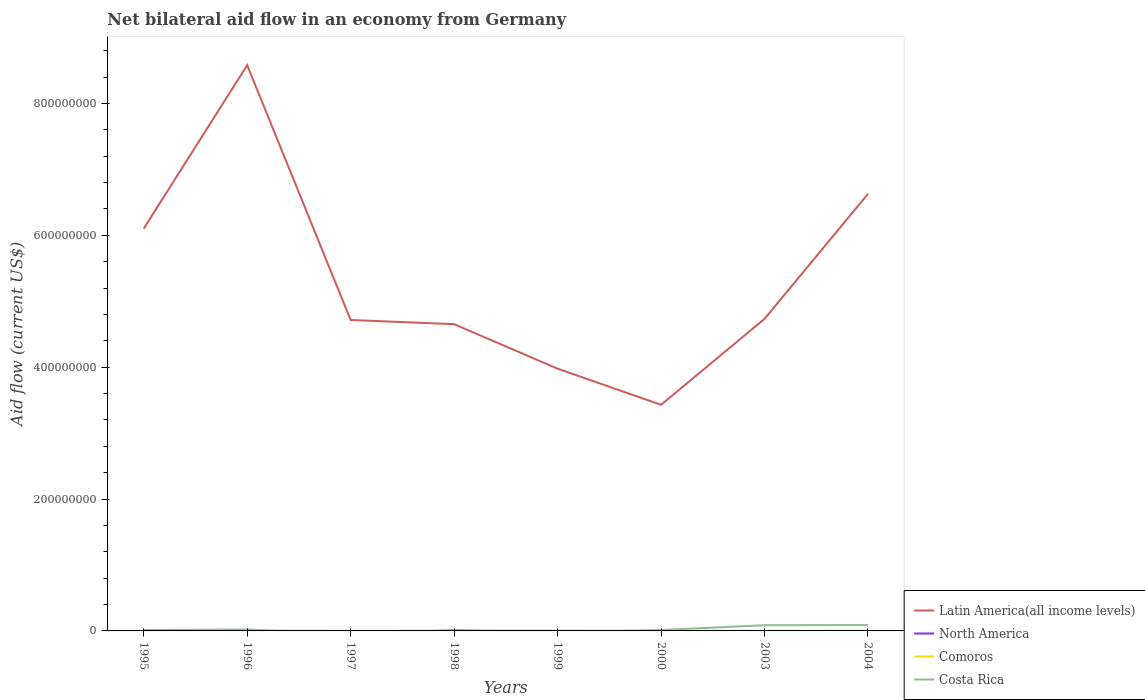Across all years, what is the maximum net bilateral aid flow in Comoros?
Your answer should be very brief. 2.00e+04. What is the total net bilateral aid flow in Latin America(all income levels) in the graph?
Provide a succinct answer. 5.15e+08. What is the difference between the highest and the second highest net bilateral aid flow in Comoros?
Keep it short and to the point. 9.30e+05. How many lines are there?
Offer a terse response. 4. How are the legend labels stacked?
Give a very brief answer. Vertical. What is the title of the graph?
Your answer should be very brief. Net bilateral aid flow in an economy from Germany. What is the Aid flow (current US$) in Latin America(all income levels) in 1995?
Your answer should be compact. 6.10e+08. What is the Aid flow (current US$) in Costa Rica in 1995?
Offer a terse response. 1.34e+06. What is the Aid flow (current US$) of Latin America(all income levels) in 1996?
Your response must be concise. 8.58e+08. What is the Aid flow (current US$) in North America in 1996?
Offer a very short reply. 0. What is the Aid flow (current US$) of Comoros in 1996?
Offer a very short reply. 9.50e+05. What is the Aid flow (current US$) of Costa Rica in 1996?
Offer a very short reply. 2.22e+06. What is the Aid flow (current US$) of Latin America(all income levels) in 1997?
Your answer should be compact. 4.72e+08. What is the Aid flow (current US$) in North America in 1997?
Provide a short and direct response. 0. What is the Aid flow (current US$) of Comoros in 1997?
Give a very brief answer. 2.60e+05. What is the Aid flow (current US$) of Latin America(all income levels) in 1998?
Keep it short and to the point. 4.65e+08. What is the Aid flow (current US$) in Comoros in 1998?
Your answer should be very brief. 6.00e+05. What is the Aid flow (current US$) in Costa Rica in 1998?
Your answer should be very brief. 1.49e+06. What is the Aid flow (current US$) of Latin America(all income levels) in 1999?
Give a very brief answer. 3.98e+08. What is the Aid flow (current US$) of North America in 1999?
Ensure brevity in your answer.  2.00e+04. What is the Aid flow (current US$) in Comoros in 1999?
Give a very brief answer. 4.20e+05. What is the Aid flow (current US$) in Latin America(all income levels) in 2000?
Your answer should be compact. 3.43e+08. What is the Aid flow (current US$) of North America in 2000?
Ensure brevity in your answer.  10000. What is the Aid flow (current US$) in Costa Rica in 2000?
Make the answer very short. 1.39e+06. What is the Aid flow (current US$) of Latin America(all income levels) in 2003?
Your answer should be compact. 4.73e+08. What is the Aid flow (current US$) of North America in 2003?
Keep it short and to the point. 10000. What is the Aid flow (current US$) of Costa Rica in 2003?
Provide a short and direct response. 8.62e+06. What is the Aid flow (current US$) in Latin America(all income levels) in 2004?
Ensure brevity in your answer.  6.63e+08. What is the Aid flow (current US$) of North America in 2004?
Your answer should be very brief. 3.00e+04. What is the Aid flow (current US$) in Costa Rica in 2004?
Ensure brevity in your answer.  8.91e+06. Across all years, what is the maximum Aid flow (current US$) of Latin America(all income levels)?
Provide a succinct answer. 8.58e+08. Across all years, what is the maximum Aid flow (current US$) of North America?
Your response must be concise. 3.00e+04. Across all years, what is the maximum Aid flow (current US$) of Comoros?
Keep it short and to the point. 9.50e+05. Across all years, what is the maximum Aid flow (current US$) of Costa Rica?
Provide a short and direct response. 8.91e+06. Across all years, what is the minimum Aid flow (current US$) in Latin America(all income levels)?
Provide a short and direct response. 3.43e+08. Across all years, what is the minimum Aid flow (current US$) in Comoros?
Your answer should be very brief. 2.00e+04. What is the total Aid flow (current US$) in Latin America(all income levels) in the graph?
Your answer should be compact. 4.28e+09. What is the total Aid flow (current US$) in Comoros in the graph?
Provide a succinct answer. 2.53e+06. What is the total Aid flow (current US$) of Costa Rica in the graph?
Make the answer very short. 2.40e+07. What is the difference between the Aid flow (current US$) in Latin America(all income levels) in 1995 and that in 1996?
Provide a succinct answer. -2.48e+08. What is the difference between the Aid flow (current US$) of Comoros in 1995 and that in 1996?
Your response must be concise. -7.40e+05. What is the difference between the Aid flow (current US$) in Costa Rica in 1995 and that in 1996?
Make the answer very short. -8.80e+05. What is the difference between the Aid flow (current US$) of Latin America(all income levels) in 1995 and that in 1997?
Provide a succinct answer. 1.39e+08. What is the difference between the Aid flow (current US$) in Latin America(all income levels) in 1995 and that in 1998?
Keep it short and to the point. 1.45e+08. What is the difference between the Aid flow (current US$) of Comoros in 1995 and that in 1998?
Ensure brevity in your answer.  -3.90e+05. What is the difference between the Aid flow (current US$) in Costa Rica in 1995 and that in 1998?
Provide a short and direct response. -1.50e+05. What is the difference between the Aid flow (current US$) in Latin America(all income levels) in 1995 and that in 1999?
Provide a succinct answer. 2.12e+08. What is the difference between the Aid flow (current US$) in Comoros in 1995 and that in 1999?
Offer a terse response. -2.10e+05. What is the difference between the Aid flow (current US$) of Latin America(all income levels) in 1995 and that in 2000?
Provide a short and direct response. 2.67e+08. What is the difference between the Aid flow (current US$) in Comoros in 1995 and that in 2000?
Provide a succinct answer. 1.80e+05. What is the difference between the Aid flow (current US$) in Latin America(all income levels) in 1995 and that in 2003?
Ensure brevity in your answer.  1.37e+08. What is the difference between the Aid flow (current US$) in Comoros in 1995 and that in 2003?
Your answer should be compact. 1.70e+05. What is the difference between the Aid flow (current US$) in Costa Rica in 1995 and that in 2003?
Ensure brevity in your answer.  -7.28e+06. What is the difference between the Aid flow (current US$) of Latin America(all income levels) in 1995 and that in 2004?
Your answer should be compact. -5.27e+07. What is the difference between the Aid flow (current US$) of Comoros in 1995 and that in 2004?
Give a very brief answer. 1.90e+05. What is the difference between the Aid flow (current US$) of Costa Rica in 1995 and that in 2004?
Ensure brevity in your answer.  -7.57e+06. What is the difference between the Aid flow (current US$) of Latin America(all income levels) in 1996 and that in 1997?
Provide a short and direct response. 3.87e+08. What is the difference between the Aid flow (current US$) in Comoros in 1996 and that in 1997?
Your answer should be compact. 6.90e+05. What is the difference between the Aid flow (current US$) in Latin America(all income levels) in 1996 and that in 1998?
Your answer should be compact. 3.93e+08. What is the difference between the Aid flow (current US$) of Costa Rica in 1996 and that in 1998?
Make the answer very short. 7.30e+05. What is the difference between the Aid flow (current US$) of Latin America(all income levels) in 1996 and that in 1999?
Offer a very short reply. 4.60e+08. What is the difference between the Aid flow (current US$) in Comoros in 1996 and that in 1999?
Provide a short and direct response. 5.30e+05. What is the difference between the Aid flow (current US$) of Latin America(all income levels) in 1996 and that in 2000?
Provide a succinct answer. 5.15e+08. What is the difference between the Aid flow (current US$) of Comoros in 1996 and that in 2000?
Provide a succinct answer. 9.20e+05. What is the difference between the Aid flow (current US$) of Costa Rica in 1996 and that in 2000?
Provide a short and direct response. 8.30e+05. What is the difference between the Aid flow (current US$) in Latin America(all income levels) in 1996 and that in 2003?
Provide a short and direct response. 3.85e+08. What is the difference between the Aid flow (current US$) in Comoros in 1996 and that in 2003?
Ensure brevity in your answer.  9.10e+05. What is the difference between the Aid flow (current US$) of Costa Rica in 1996 and that in 2003?
Offer a very short reply. -6.40e+06. What is the difference between the Aid flow (current US$) of Latin America(all income levels) in 1996 and that in 2004?
Make the answer very short. 1.95e+08. What is the difference between the Aid flow (current US$) of Comoros in 1996 and that in 2004?
Offer a terse response. 9.30e+05. What is the difference between the Aid flow (current US$) in Costa Rica in 1996 and that in 2004?
Offer a terse response. -6.69e+06. What is the difference between the Aid flow (current US$) in Latin America(all income levels) in 1997 and that in 1998?
Your response must be concise. 6.31e+06. What is the difference between the Aid flow (current US$) in Latin America(all income levels) in 1997 and that in 1999?
Provide a short and direct response. 7.38e+07. What is the difference between the Aid flow (current US$) of Comoros in 1997 and that in 1999?
Ensure brevity in your answer.  -1.60e+05. What is the difference between the Aid flow (current US$) in Latin America(all income levels) in 1997 and that in 2000?
Make the answer very short. 1.29e+08. What is the difference between the Aid flow (current US$) in Comoros in 1997 and that in 2000?
Offer a very short reply. 2.30e+05. What is the difference between the Aid flow (current US$) in Latin America(all income levels) in 1997 and that in 2003?
Provide a short and direct response. -1.68e+06. What is the difference between the Aid flow (current US$) of Latin America(all income levels) in 1997 and that in 2004?
Your response must be concise. -1.91e+08. What is the difference between the Aid flow (current US$) in Comoros in 1997 and that in 2004?
Your answer should be compact. 2.40e+05. What is the difference between the Aid flow (current US$) in Latin America(all income levels) in 1998 and that in 1999?
Ensure brevity in your answer.  6.75e+07. What is the difference between the Aid flow (current US$) in North America in 1998 and that in 1999?
Provide a short and direct response. 0. What is the difference between the Aid flow (current US$) in Comoros in 1998 and that in 1999?
Ensure brevity in your answer.  1.80e+05. What is the difference between the Aid flow (current US$) in Latin America(all income levels) in 1998 and that in 2000?
Offer a very short reply. 1.22e+08. What is the difference between the Aid flow (current US$) in Comoros in 1998 and that in 2000?
Make the answer very short. 5.70e+05. What is the difference between the Aid flow (current US$) in Costa Rica in 1998 and that in 2000?
Keep it short and to the point. 1.00e+05. What is the difference between the Aid flow (current US$) in Latin America(all income levels) in 1998 and that in 2003?
Your answer should be very brief. -7.99e+06. What is the difference between the Aid flow (current US$) of Comoros in 1998 and that in 2003?
Offer a terse response. 5.60e+05. What is the difference between the Aid flow (current US$) of Costa Rica in 1998 and that in 2003?
Offer a terse response. -7.13e+06. What is the difference between the Aid flow (current US$) of Latin America(all income levels) in 1998 and that in 2004?
Your answer should be compact. -1.98e+08. What is the difference between the Aid flow (current US$) of Comoros in 1998 and that in 2004?
Your answer should be compact. 5.80e+05. What is the difference between the Aid flow (current US$) in Costa Rica in 1998 and that in 2004?
Provide a short and direct response. -7.42e+06. What is the difference between the Aid flow (current US$) in Latin America(all income levels) in 1999 and that in 2000?
Offer a terse response. 5.48e+07. What is the difference between the Aid flow (current US$) in North America in 1999 and that in 2000?
Ensure brevity in your answer.  10000. What is the difference between the Aid flow (current US$) in Latin America(all income levels) in 1999 and that in 2003?
Your answer should be very brief. -7.55e+07. What is the difference between the Aid flow (current US$) of Comoros in 1999 and that in 2003?
Offer a very short reply. 3.80e+05. What is the difference between the Aid flow (current US$) of Latin America(all income levels) in 1999 and that in 2004?
Make the answer very short. -2.65e+08. What is the difference between the Aid flow (current US$) in North America in 1999 and that in 2004?
Provide a succinct answer. -10000. What is the difference between the Aid flow (current US$) of Latin America(all income levels) in 2000 and that in 2003?
Offer a terse response. -1.30e+08. What is the difference between the Aid flow (current US$) of Comoros in 2000 and that in 2003?
Make the answer very short. -10000. What is the difference between the Aid flow (current US$) in Costa Rica in 2000 and that in 2003?
Offer a terse response. -7.23e+06. What is the difference between the Aid flow (current US$) in Latin America(all income levels) in 2000 and that in 2004?
Offer a terse response. -3.20e+08. What is the difference between the Aid flow (current US$) of Comoros in 2000 and that in 2004?
Offer a terse response. 10000. What is the difference between the Aid flow (current US$) of Costa Rica in 2000 and that in 2004?
Your answer should be very brief. -7.52e+06. What is the difference between the Aid flow (current US$) in Latin America(all income levels) in 2003 and that in 2004?
Provide a succinct answer. -1.90e+08. What is the difference between the Aid flow (current US$) in North America in 2003 and that in 2004?
Your response must be concise. -2.00e+04. What is the difference between the Aid flow (current US$) in Comoros in 2003 and that in 2004?
Your answer should be very brief. 2.00e+04. What is the difference between the Aid flow (current US$) of Latin America(all income levels) in 1995 and the Aid flow (current US$) of Comoros in 1996?
Offer a very short reply. 6.09e+08. What is the difference between the Aid flow (current US$) of Latin America(all income levels) in 1995 and the Aid flow (current US$) of Costa Rica in 1996?
Your answer should be very brief. 6.08e+08. What is the difference between the Aid flow (current US$) in Comoros in 1995 and the Aid flow (current US$) in Costa Rica in 1996?
Provide a succinct answer. -2.01e+06. What is the difference between the Aid flow (current US$) of Latin America(all income levels) in 1995 and the Aid flow (current US$) of Comoros in 1997?
Offer a terse response. 6.10e+08. What is the difference between the Aid flow (current US$) of Latin America(all income levels) in 1995 and the Aid flow (current US$) of North America in 1998?
Your answer should be compact. 6.10e+08. What is the difference between the Aid flow (current US$) in Latin America(all income levels) in 1995 and the Aid flow (current US$) in Comoros in 1998?
Your answer should be very brief. 6.10e+08. What is the difference between the Aid flow (current US$) in Latin America(all income levels) in 1995 and the Aid flow (current US$) in Costa Rica in 1998?
Your answer should be compact. 6.09e+08. What is the difference between the Aid flow (current US$) in Comoros in 1995 and the Aid flow (current US$) in Costa Rica in 1998?
Keep it short and to the point. -1.28e+06. What is the difference between the Aid flow (current US$) of Latin America(all income levels) in 1995 and the Aid flow (current US$) of North America in 1999?
Provide a succinct answer. 6.10e+08. What is the difference between the Aid flow (current US$) of Latin America(all income levels) in 1995 and the Aid flow (current US$) of Comoros in 1999?
Offer a very short reply. 6.10e+08. What is the difference between the Aid flow (current US$) in Latin America(all income levels) in 1995 and the Aid flow (current US$) in North America in 2000?
Give a very brief answer. 6.10e+08. What is the difference between the Aid flow (current US$) in Latin America(all income levels) in 1995 and the Aid flow (current US$) in Comoros in 2000?
Your answer should be very brief. 6.10e+08. What is the difference between the Aid flow (current US$) of Latin America(all income levels) in 1995 and the Aid flow (current US$) of Costa Rica in 2000?
Offer a terse response. 6.09e+08. What is the difference between the Aid flow (current US$) in Comoros in 1995 and the Aid flow (current US$) in Costa Rica in 2000?
Make the answer very short. -1.18e+06. What is the difference between the Aid flow (current US$) in Latin America(all income levels) in 1995 and the Aid flow (current US$) in North America in 2003?
Provide a succinct answer. 6.10e+08. What is the difference between the Aid flow (current US$) in Latin America(all income levels) in 1995 and the Aid flow (current US$) in Comoros in 2003?
Provide a succinct answer. 6.10e+08. What is the difference between the Aid flow (current US$) of Latin America(all income levels) in 1995 and the Aid flow (current US$) of Costa Rica in 2003?
Ensure brevity in your answer.  6.01e+08. What is the difference between the Aid flow (current US$) in Comoros in 1995 and the Aid flow (current US$) in Costa Rica in 2003?
Offer a terse response. -8.41e+06. What is the difference between the Aid flow (current US$) of Latin America(all income levels) in 1995 and the Aid flow (current US$) of North America in 2004?
Your answer should be compact. 6.10e+08. What is the difference between the Aid flow (current US$) of Latin America(all income levels) in 1995 and the Aid flow (current US$) of Comoros in 2004?
Your response must be concise. 6.10e+08. What is the difference between the Aid flow (current US$) of Latin America(all income levels) in 1995 and the Aid flow (current US$) of Costa Rica in 2004?
Offer a terse response. 6.01e+08. What is the difference between the Aid flow (current US$) of Comoros in 1995 and the Aid flow (current US$) of Costa Rica in 2004?
Offer a very short reply. -8.70e+06. What is the difference between the Aid flow (current US$) of Latin America(all income levels) in 1996 and the Aid flow (current US$) of Comoros in 1997?
Give a very brief answer. 8.58e+08. What is the difference between the Aid flow (current US$) in Latin America(all income levels) in 1996 and the Aid flow (current US$) in North America in 1998?
Ensure brevity in your answer.  8.58e+08. What is the difference between the Aid flow (current US$) in Latin America(all income levels) in 1996 and the Aid flow (current US$) in Comoros in 1998?
Offer a very short reply. 8.57e+08. What is the difference between the Aid flow (current US$) of Latin America(all income levels) in 1996 and the Aid flow (current US$) of Costa Rica in 1998?
Offer a very short reply. 8.57e+08. What is the difference between the Aid flow (current US$) in Comoros in 1996 and the Aid flow (current US$) in Costa Rica in 1998?
Offer a very short reply. -5.40e+05. What is the difference between the Aid flow (current US$) in Latin America(all income levels) in 1996 and the Aid flow (current US$) in North America in 1999?
Keep it short and to the point. 8.58e+08. What is the difference between the Aid flow (current US$) of Latin America(all income levels) in 1996 and the Aid flow (current US$) of Comoros in 1999?
Keep it short and to the point. 8.58e+08. What is the difference between the Aid flow (current US$) of Latin America(all income levels) in 1996 and the Aid flow (current US$) of North America in 2000?
Offer a very short reply. 8.58e+08. What is the difference between the Aid flow (current US$) of Latin America(all income levels) in 1996 and the Aid flow (current US$) of Comoros in 2000?
Ensure brevity in your answer.  8.58e+08. What is the difference between the Aid flow (current US$) in Latin America(all income levels) in 1996 and the Aid flow (current US$) in Costa Rica in 2000?
Ensure brevity in your answer.  8.57e+08. What is the difference between the Aid flow (current US$) in Comoros in 1996 and the Aid flow (current US$) in Costa Rica in 2000?
Give a very brief answer. -4.40e+05. What is the difference between the Aid flow (current US$) in Latin America(all income levels) in 1996 and the Aid flow (current US$) in North America in 2003?
Offer a terse response. 8.58e+08. What is the difference between the Aid flow (current US$) of Latin America(all income levels) in 1996 and the Aid flow (current US$) of Comoros in 2003?
Your answer should be compact. 8.58e+08. What is the difference between the Aid flow (current US$) in Latin America(all income levels) in 1996 and the Aid flow (current US$) in Costa Rica in 2003?
Provide a succinct answer. 8.49e+08. What is the difference between the Aid flow (current US$) of Comoros in 1996 and the Aid flow (current US$) of Costa Rica in 2003?
Provide a succinct answer. -7.67e+06. What is the difference between the Aid flow (current US$) in Latin America(all income levels) in 1996 and the Aid flow (current US$) in North America in 2004?
Your answer should be compact. 8.58e+08. What is the difference between the Aid flow (current US$) of Latin America(all income levels) in 1996 and the Aid flow (current US$) of Comoros in 2004?
Make the answer very short. 8.58e+08. What is the difference between the Aid flow (current US$) of Latin America(all income levels) in 1996 and the Aid flow (current US$) of Costa Rica in 2004?
Your answer should be compact. 8.49e+08. What is the difference between the Aid flow (current US$) in Comoros in 1996 and the Aid flow (current US$) in Costa Rica in 2004?
Your answer should be very brief. -7.96e+06. What is the difference between the Aid flow (current US$) in Latin America(all income levels) in 1997 and the Aid flow (current US$) in North America in 1998?
Give a very brief answer. 4.72e+08. What is the difference between the Aid flow (current US$) in Latin America(all income levels) in 1997 and the Aid flow (current US$) in Comoros in 1998?
Your answer should be very brief. 4.71e+08. What is the difference between the Aid flow (current US$) in Latin America(all income levels) in 1997 and the Aid flow (current US$) in Costa Rica in 1998?
Offer a very short reply. 4.70e+08. What is the difference between the Aid flow (current US$) in Comoros in 1997 and the Aid flow (current US$) in Costa Rica in 1998?
Offer a terse response. -1.23e+06. What is the difference between the Aid flow (current US$) of Latin America(all income levels) in 1997 and the Aid flow (current US$) of North America in 1999?
Make the answer very short. 4.72e+08. What is the difference between the Aid flow (current US$) in Latin America(all income levels) in 1997 and the Aid flow (current US$) in Comoros in 1999?
Your answer should be compact. 4.71e+08. What is the difference between the Aid flow (current US$) in Latin America(all income levels) in 1997 and the Aid flow (current US$) in North America in 2000?
Your response must be concise. 4.72e+08. What is the difference between the Aid flow (current US$) of Latin America(all income levels) in 1997 and the Aid flow (current US$) of Comoros in 2000?
Your answer should be very brief. 4.72e+08. What is the difference between the Aid flow (current US$) of Latin America(all income levels) in 1997 and the Aid flow (current US$) of Costa Rica in 2000?
Your response must be concise. 4.70e+08. What is the difference between the Aid flow (current US$) in Comoros in 1997 and the Aid flow (current US$) in Costa Rica in 2000?
Make the answer very short. -1.13e+06. What is the difference between the Aid flow (current US$) in Latin America(all income levels) in 1997 and the Aid flow (current US$) in North America in 2003?
Provide a short and direct response. 4.72e+08. What is the difference between the Aid flow (current US$) in Latin America(all income levels) in 1997 and the Aid flow (current US$) in Comoros in 2003?
Your answer should be very brief. 4.72e+08. What is the difference between the Aid flow (current US$) in Latin America(all income levels) in 1997 and the Aid flow (current US$) in Costa Rica in 2003?
Your answer should be compact. 4.63e+08. What is the difference between the Aid flow (current US$) in Comoros in 1997 and the Aid flow (current US$) in Costa Rica in 2003?
Ensure brevity in your answer.  -8.36e+06. What is the difference between the Aid flow (current US$) in Latin America(all income levels) in 1997 and the Aid flow (current US$) in North America in 2004?
Keep it short and to the point. 4.72e+08. What is the difference between the Aid flow (current US$) of Latin America(all income levels) in 1997 and the Aid flow (current US$) of Comoros in 2004?
Provide a short and direct response. 4.72e+08. What is the difference between the Aid flow (current US$) in Latin America(all income levels) in 1997 and the Aid flow (current US$) in Costa Rica in 2004?
Your answer should be very brief. 4.63e+08. What is the difference between the Aid flow (current US$) of Comoros in 1997 and the Aid flow (current US$) of Costa Rica in 2004?
Your answer should be compact. -8.65e+06. What is the difference between the Aid flow (current US$) of Latin America(all income levels) in 1998 and the Aid flow (current US$) of North America in 1999?
Your response must be concise. 4.65e+08. What is the difference between the Aid flow (current US$) of Latin America(all income levels) in 1998 and the Aid flow (current US$) of Comoros in 1999?
Provide a short and direct response. 4.65e+08. What is the difference between the Aid flow (current US$) in North America in 1998 and the Aid flow (current US$) in Comoros in 1999?
Your answer should be very brief. -4.00e+05. What is the difference between the Aid flow (current US$) of Latin America(all income levels) in 1998 and the Aid flow (current US$) of North America in 2000?
Ensure brevity in your answer.  4.65e+08. What is the difference between the Aid flow (current US$) in Latin America(all income levels) in 1998 and the Aid flow (current US$) in Comoros in 2000?
Make the answer very short. 4.65e+08. What is the difference between the Aid flow (current US$) in Latin America(all income levels) in 1998 and the Aid flow (current US$) in Costa Rica in 2000?
Your answer should be compact. 4.64e+08. What is the difference between the Aid flow (current US$) of North America in 1998 and the Aid flow (current US$) of Costa Rica in 2000?
Provide a short and direct response. -1.37e+06. What is the difference between the Aid flow (current US$) in Comoros in 1998 and the Aid flow (current US$) in Costa Rica in 2000?
Your answer should be very brief. -7.90e+05. What is the difference between the Aid flow (current US$) of Latin America(all income levels) in 1998 and the Aid flow (current US$) of North America in 2003?
Offer a terse response. 4.65e+08. What is the difference between the Aid flow (current US$) of Latin America(all income levels) in 1998 and the Aid flow (current US$) of Comoros in 2003?
Offer a very short reply. 4.65e+08. What is the difference between the Aid flow (current US$) of Latin America(all income levels) in 1998 and the Aid flow (current US$) of Costa Rica in 2003?
Your response must be concise. 4.57e+08. What is the difference between the Aid flow (current US$) in North America in 1998 and the Aid flow (current US$) in Costa Rica in 2003?
Provide a short and direct response. -8.60e+06. What is the difference between the Aid flow (current US$) of Comoros in 1998 and the Aid flow (current US$) of Costa Rica in 2003?
Make the answer very short. -8.02e+06. What is the difference between the Aid flow (current US$) in Latin America(all income levels) in 1998 and the Aid flow (current US$) in North America in 2004?
Ensure brevity in your answer.  4.65e+08. What is the difference between the Aid flow (current US$) in Latin America(all income levels) in 1998 and the Aid flow (current US$) in Comoros in 2004?
Offer a terse response. 4.65e+08. What is the difference between the Aid flow (current US$) in Latin America(all income levels) in 1998 and the Aid flow (current US$) in Costa Rica in 2004?
Make the answer very short. 4.56e+08. What is the difference between the Aid flow (current US$) in North America in 1998 and the Aid flow (current US$) in Comoros in 2004?
Provide a succinct answer. 0. What is the difference between the Aid flow (current US$) of North America in 1998 and the Aid flow (current US$) of Costa Rica in 2004?
Keep it short and to the point. -8.89e+06. What is the difference between the Aid flow (current US$) of Comoros in 1998 and the Aid flow (current US$) of Costa Rica in 2004?
Make the answer very short. -8.31e+06. What is the difference between the Aid flow (current US$) of Latin America(all income levels) in 1999 and the Aid flow (current US$) of North America in 2000?
Your answer should be compact. 3.98e+08. What is the difference between the Aid flow (current US$) in Latin America(all income levels) in 1999 and the Aid flow (current US$) in Comoros in 2000?
Make the answer very short. 3.98e+08. What is the difference between the Aid flow (current US$) of Latin America(all income levels) in 1999 and the Aid flow (current US$) of Costa Rica in 2000?
Provide a succinct answer. 3.96e+08. What is the difference between the Aid flow (current US$) in North America in 1999 and the Aid flow (current US$) in Costa Rica in 2000?
Ensure brevity in your answer.  -1.37e+06. What is the difference between the Aid flow (current US$) in Comoros in 1999 and the Aid flow (current US$) in Costa Rica in 2000?
Your answer should be very brief. -9.70e+05. What is the difference between the Aid flow (current US$) of Latin America(all income levels) in 1999 and the Aid flow (current US$) of North America in 2003?
Give a very brief answer. 3.98e+08. What is the difference between the Aid flow (current US$) in Latin America(all income levels) in 1999 and the Aid flow (current US$) in Comoros in 2003?
Keep it short and to the point. 3.98e+08. What is the difference between the Aid flow (current US$) in Latin America(all income levels) in 1999 and the Aid flow (current US$) in Costa Rica in 2003?
Give a very brief answer. 3.89e+08. What is the difference between the Aid flow (current US$) of North America in 1999 and the Aid flow (current US$) of Costa Rica in 2003?
Offer a very short reply. -8.60e+06. What is the difference between the Aid flow (current US$) in Comoros in 1999 and the Aid flow (current US$) in Costa Rica in 2003?
Provide a succinct answer. -8.20e+06. What is the difference between the Aid flow (current US$) of Latin America(all income levels) in 1999 and the Aid flow (current US$) of North America in 2004?
Your answer should be compact. 3.98e+08. What is the difference between the Aid flow (current US$) in Latin America(all income levels) in 1999 and the Aid flow (current US$) in Comoros in 2004?
Offer a very short reply. 3.98e+08. What is the difference between the Aid flow (current US$) of Latin America(all income levels) in 1999 and the Aid flow (current US$) of Costa Rica in 2004?
Provide a succinct answer. 3.89e+08. What is the difference between the Aid flow (current US$) of North America in 1999 and the Aid flow (current US$) of Costa Rica in 2004?
Make the answer very short. -8.89e+06. What is the difference between the Aid flow (current US$) in Comoros in 1999 and the Aid flow (current US$) in Costa Rica in 2004?
Give a very brief answer. -8.49e+06. What is the difference between the Aid flow (current US$) in Latin America(all income levels) in 2000 and the Aid flow (current US$) in North America in 2003?
Keep it short and to the point. 3.43e+08. What is the difference between the Aid flow (current US$) in Latin America(all income levels) in 2000 and the Aid flow (current US$) in Comoros in 2003?
Give a very brief answer. 3.43e+08. What is the difference between the Aid flow (current US$) of Latin America(all income levels) in 2000 and the Aid flow (current US$) of Costa Rica in 2003?
Provide a short and direct response. 3.34e+08. What is the difference between the Aid flow (current US$) of North America in 2000 and the Aid flow (current US$) of Costa Rica in 2003?
Ensure brevity in your answer.  -8.61e+06. What is the difference between the Aid flow (current US$) of Comoros in 2000 and the Aid flow (current US$) of Costa Rica in 2003?
Offer a very short reply. -8.59e+06. What is the difference between the Aid flow (current US$) of Latin America(all income levels) in 2000 and the Aid flow (current US$) of North America in 2004?
Make the answer very short. 3.43e+08. What is the difference between the Aid flow (current US$) in Latin America(all income levels) in 2000 and the Aid flow (current US$) in Comoros in 2004?
Offer a terse response. 3.43e+08. What is the difference between the Aid flow (current US$) in Latin America(all income levels) in 2000 and the Aid flow (current US$) in Costa Rica in 2004?
Make the answer very short. 3.34e+08. What is the difference between the Aid flow (current US$) of North America in 2000 and the Aid flow (current US$) of Comoros in 2004?
Your answer should be compact. -10000. What is the difference between the Aid flow (current US$) in North America in 2000 and the Aid flow (current US$) in Costa Rica in 2004?
Ensure brevity in your answer.  -8.90e+06. What is the difference between the Aid flow (current US$) of Comoros in 2000 and the Aid flow (current US$) of Costa Rica in 2004?
Offer a very short reply. -8.88e+06. What is the difference between the Aid flow (current US$) in Latin America(all income levels) in 2003 and the Aid flow (current US$) in North America in 2004?
Your answer should be compact. 4.73e+08. What is the difference between the Aid flow (current US$) in Latin America(all income levels) in 2003 and the Aid flow (current US$) in Comoros in 2004?
Offer a very short reply. 4.73e+08. What is the difference between the Aid flow (current US$) in Latin America(all income levels) in 2003 and the Aid flow (current US$) in Costa Rica in 2004?
Offer a very short reply. 4.64e+08. What is the difference between the Aid flow (current US$) in North America in 2003 and the Aid flow (current US$) in Costa Rica in 2004?
Ensure brevity in your answer.  -8.90e+06. What is the difference between the Aid flow (current US$) in Comoros in 2003 and the Aid flow (current US$) in Costa Rica in 2004?
Offer a terse response. -8.87e+06. What is the average Aid flow (current US$) of Latin America(all income levels) per year?
Your answer should be very brief. 5.35e+08. What is the average Aid flow (current US$) of North America per year?
Give a very brief answer. 1.12e+04. What is the average Aid flow (current US$) of Comoros per year?
Your answer should be compact. 3.16e+05. What is the average Aid flow (current US$) of Costa Rica per year?
Provide a succinct answer. 3.00e+06. In the year 1995, what is the difference between the Aid flow (current US$) in Latin America(all income levels) and Aid flow (current US$) in Comoros?
Make the answer very short. 6.10e+08. In the year 1995, what is the difference between the Aid flow (current US$) in Latin America(all income levels) and Aid flow (current US$) in Costa Rica?
Give a very brief answer. 6.09e+08. In the year 1995, what is the difference between the Aid flow (current US$) in Comoros and Aid flow (current US$) in Costa Rica?
Your answer should be compact. -1.13e+06. In the year 1996, what is the difference between the Aid flow (current US$) in Latin America(all income levels) and Aid flow (current US$) in Comoros?
Make the answer very short. 8.57e+08. In the year 1996, what is the difference between the Aid flow (current US$) of Latin America(all income levels) and Aid flow (current US$) of Costa Rica?
Your response must be concise. 8.56e+08. In the year 1996, what is the difference between the Aid flow (current US$) in Comoros and Aid flow (current US$) in Costa Rica?
Give a very brief answer. -1.27e+06. In the year 1997, what is the difference between the Aid flow (current US$) in Latin America(all income levels) and Aid flow (current US$) in Comoros?
Offer a terse response. 4.71e+08. In the year 1998, what is the difference between the Aid flow (current US$) of Latin America(all income levels) and Aid flow (current US$) of North America?
Offer a very short reply. 4.65e+08. In the year 1998, what is the difference between the Aid flow (current US$) in Latin America(all income levels) and Aid flow (current US$) in Comoros?
Provide a succinct answer. 4.65e+08. In the year 1998, what is the difference between the Aid flow (current US$) of Latin America(all income levels) and Aid flow (current US$) of Costa Rica?
Offer a very short reply. 4.64e+08. In the year 1998, what is the difference between the Aid flow (current US$) of North America and Aid flow (current US$) of Comoros?
Provide a succinct answer. -5.80e+05. In the year 1998, what is the difference between the Aid flow (current US$) of North America and Aid flow (current US$) of Costa Rica?
Make the answer very short. -1.47e+06. In the year 1998, what is the difference between the Aid flow (current US$) of Comoros and Aid flow (current US$) of Costa Rica?
Ensure brevity in your answer.  -8.90e+05. In the year 1999, what is the difference between the Aid flow (current US$) of Latin America(all income levels) and Aid flow (current US$) of North America?
Provide a short and direct response. 3.98e+08. In the year 1999, what is the difference between the Aid flow (current US$) of Latin America(all income levels) and Aid flow (current US$) of Comoros?
Offer a very short reply. 3.97e+08. In the year 1999, what is the difference between the Aid flow (current US$) of North America and Aid flow (current US$) of Comoros?
Keep it short and to the point. -4.00e+05. In the year 2000, what is the difference between the Aid flow (current US$) in Latin America(all income levels) and Aid flow (current US$) in North America?
Your answer should be compact. 3.43e+08. In the year 2000, what is the difference between the Aid flow (current US$) of Latin America(all income levels) and Aid flow (current US$) of Comoros?
Provide a short and direct response. 3.43e+08. In the year 2000, what is the difference between the Aid flow (current US$) of Latin America(all income levels) and Aid flow (current US$) of Costa Rica?
Offer a terse response. 3.42e+08. In the year 2000, what is the difference between the Aid flow (current US$) in North America and Aid flow (current US$) in Comoros?
Make the answer very short. -2.00e+04. In the year 2000, what is the difference between the Aid flow (current US$) in North America and Aid flow (current US$) in Costa Rica?
Give a very brief answer. -1.38e+06. In the year 2000, what is the difference between the Aid flow (current US$) of Comoros and Aid flow (current US$) of Costa Rica?
Keep it short and to the point. -1.36e+06. In the year 2003, what is the difference between the Aid flow (current US$) of Latin America(all income levels) and Aid flow (current US$) of North America?
Make the answer very short. 4.73e+08. In the year 2003, what is the difference between the Aid flow (current US$) in Latin America(all income levels) and Aid flow (current US$) in Comoros?
Your answer should be very brief. 4.73e+08. In the year 2003, what is the difference between the Aid flow (current US$) of Latin America(all income levels) and Aid flow (current US$) of Costa Rica?
Offer a terse response. 4.65e+08. In the year 2003, what is the difference between the Aid flow (current US$) in North America and Aid flow (current US$) in Comoros?
Your answer should be compact. -3.00e+04. In the year 2003, what is the difference between the Aid flow (current US$) of North America and Aid flow (current US$) of Costa Rica?
Offer a very short reply. -8.61e+06. In the year 2003, what is the difference between the Aid flow (current US$) in Comoros and Aid flow (current US$) in Costa Rica?
Ensure brevity in your answer.  -8.58e+06. In the year 2004, what is the difference between the Aid flow (current US$) of Latin America(all income levels) and Aid flow (current US$) of North America?
Offer a terse response. 6.63e+08. In the year 2004, what is the difference between the Aid flow (current US$) in Latin America(all income levels) and Aid flow (current US$) in Comoros?
Keep it short and to the point. 6.63e+08. In the year 2004, what is the difference between the Aid flow (current US$) of Latin America(all income levels) and Aid flow (current US$) of Costa Rica?
Your answer should be very brief. 6.54e+08. In the year 2004, what is the difference between the Aid flow (current US$) in North America and Aid flow (current US$) in Comoros?
Offer a very short reply. 10000. In the year 2004, what is the difference between the Aid flow (current US$) in North America and Aid flow (current US$) in Costa Rica?
Your answer should be very brief. -8.88e+06. In the year 2004, what is the difference between the Aid flow (current US$) in Comoros and Aid flow (current US$) in Costa Rica?
Offer a very short reply. -8.89e+06. What is the ratio of the Aid flow (current US$) in Latin America(all income levels) in 1995 to that in 1996?
Offer a terse response. 0.71. What is the ratio of the Aid flow (current US$) in Comoros in 1995 to that in 1996?
Offer a very short reply. 0.22. What is the ratio of the Aid flow (current US$) of Costa Rica in 1995 to that in 1996?
Keep it short and to the point. 0.6. What is the ratio of the Aid flow (current US$) in Latin America(all income levels) in 1995 to that in 1997?
Your answer should be very brief. 1.29. What is the ratio of the Aid flow (current US$) in Comoros in 1995 to that in 1997?
Provide a succinct answer. 0.81. What is the ratio of the Aid flow (current US$) in Latin America(all income levels) in 1995 to that in 1998?
Provide a short and direct response. 1.31. What is the ratio of the Aid flow (current US$) in Comoros in 1995 to that in 1998?
Offer a very short reply. 0.35. What is the ratio of the Aid flow (current US$) in Costa Rica in 1995 to that in 1998?
Keep it short and to the point. 0.9. What is the ratio of the Aid flow (current US$) of Latin America(all income levels) in 1995 to that in 1999?
Provide a short and direct response. 1.53. What is the ratio of the Aid flow (current US$) in Latin America(all income levels) in 1995 to that in 2000?
Your answer should be very brief. 1.78. What is the ratio of the Aid flow (current US$) in Comoros in 1995 to that in 2000?
Give a very brief answer. 7. What is the ratio of the Aid flow (current US$) of Latin America(all income levels) in 1995 to that in 2003?
Your answer should be very brief. 1.29. What is the ratio of the Aid flow (current US$) of Comoros in 1995 to that in 2003?
Provide a short and direct response. 5.25. What is the ratio of the Aid flow (current US$) of Costa Rica in 1995 to that in 2003?
Give a very brief answer. 0.16. What is the ratio of the Aid flow (current US$) in Latin America(all income levels) in 1995 to that in 2004?
Offer a terse response. 0.92. What is the ratio of the Aid flow (current US$) of Comoros in 1995 to that in 2004?
Keep it short and to the point. 10.5. What is the ratio of the Aid flow (current US$) of Costa Rica in 1995 to that in 2004?
Provide a short and direct response. 0.15. What is the ratio of the Aid flow (current US$) in Latin America(all income levels) in 1996 to that in 1997?
Provide a succinct answer. 1.82. What is the ratio of the Aid flow (current US$) of Comoros in 1996 to that in 1997?
Offer a very short reply. 3.65. What is the ratio of the Aid flow (current US$) in Latin America(all income levels) in 1996 to that in 1998?
Provide a succinct answer. 1.84. What is the ratio of the Aid flow (current US$) of Comoros in 1996 to that in 1998?
Your answer should be very brief. 1.58. What is the ratio of the Aid flow (current US$) of Costa Rica in 1996 to that in 1998?
Keep it short and to the point. 1.49. What is the ratio of the Aid flow (current US$) in Latin America(all income levels) in 1996 to that in 1999?
Ensure brevity in your answer.  2.16. What is the ratio of the Aid flow (current US$) of Comoros in 1996 to that in 1999?
Give a very brief answer. 2.26. What is the ratio of the Aid flow (current US$) in Latin America(all income levels) in 1996 to that in 2000?
Make the answer very short. 2.5. What is the ratio of the Aid flow (current US$) in Comoros in 1996 to that in 2000?
Your answer should be compact. 31.67. What is the ratio of the Aid flow (current US$) of Costa Rica in 1996 to that in 2000?
Keep it short and to the point. 1.6. What is the ratio of the Aid flow (current US$) of Latin America(all income levels) in 1996 to that in 2003?
Your response must be concise. 1.81. What is the ratio of the Aid flow (current US$) of Comoros in 1996 to that in 2003?
Keep it short and to the point. 23.75. What is the ratio of the Aid flow (current US$) of Costa Rica in 1996 to that in 2003?
Provide a short and direct response. 0.26. What is the ratio of the Aid flow (current US$) of Latin America(all income levels) in 1996 to that in 2004?
Make the answer very short. 1.29. What is the ratio of the Aid flow (current US$) of Comoros in 1996 to that in 2004?
Keep it short and to the point. 47.5. What is the ratio of the Aid flow (current US$) in Costa Rica in 1996 to that in 2004?
Keep it short and to the point. 0.25. What is the ratio of the Aid flow (current US$) in Latin America(all income levels) in 1997 to that in 1998?
Provide a short and direct response. 1.01. What is the ratio of the Aid flow (current US$) in Comoros in 1997 to that in 1998?
Offer a terse response. 0.43. What is the ratio of the Aid flow (current US$) in Latin America(all income levels) in 1997 to that in 1999?
Offer a very short reply. 1.19. What is the ratio of the Aid flow (current US$) of Comoros in 1997 to that in 1999?
Your answer should be very brief. 0.62. What is the ratio of the Aid flow (current US$) in Latin America(all income levels) in 1997 to that in 2000?
Give a very brief answer. 1.38. What is the ratio of the Aid flow (current US$) of Comoros in 1997 to that in 2000?
Your answer should be very brief. 8.67. What is the ratio of the Aid flow (current US$) of Latin America(all income levels) in 1997 to that in 2004?
Provide a short and direct response. 0.71. What is the ratio of the Aid flow (current US$) in Comoros in 1997 to that in 2004?
Offer a terse response. 13. What is the ratio of the Aid flow (current US$) of Latin America(all income levels) in 1998 to that in 1999?
Your answer should be compact. 1.17. What is the ratio of the Aid flow (current US$) of North America in 1998 to that in 1999?
Offer a terse response. 1. What is the ratio of the Aid flow (current US$) in Comoros in 1998 to that in 1999?
Your answer should be very brief. 1.43. What is the ratio of the Aid flow (current US$) of Latin America(all income levels) in 1998 to that in 2000?
Offer a terse response. 1.36. What is the ratio of the Aid flow (current US$) in Comoros in 1998 to that in 2000?
Your answer should be compact. 20. What is the ratio of the Aid flow (current US$) of Costa Rica in 1998 to that in 2000?
Give a very brief answer. 1.07. What is the ratio of the Aid flow (current US$) of Latin America(all income levels) in 1998 to that in 2003?
Make the answer very short. 0.98. What is the ratio of the Aid flow (current US$) of Comoros in 1998 to that in 2003?
Give a very brief answer. 15. What is the ratio of the Aid flow (current US$) of Costa Rica in 1998 to that in 2003?
Keep it short and to the point. 0.17. What is the ratio of the Aid flow (current US$) in Latin America(all income levels) in 1998 to that in 2004?
Keep it short and to the point. 0.7. What is the ratio of the Aid flow (current US$) of North America in 1998 to that in 2004?
Offer a terse response. 0.67. What is the ratio of the Aid flow (current US$) of Costa Rica in 1998 to that in 2004?
Your response must be concise. 0.17. What is the ratio of the Aid flow (current US$) in Latin America(all income levels) in 1999 to that in 2000?
Provide a short and direct response. 1.16. What is the ratio of the Aid flow (current US$) in North America in 1999 to that in 2000?
Ensure brevity in your answer.  2. What is the ratio of the Aid flow (current US$) of Latin America(all income levels) in 1999 to that in 2003?
Your response must be concise. 0.84. What is the ratio of the Aid flow (current US$) in Comoros in 1999 to that in 2003?
Your response must be concise. 10.5. What is the ratio of the Aid flow (current US$) of Latin America(all income levels) in 1999 to that in 2004?
Your answer should be compact. 0.6. What is the ratio of the Aid flow (current US$) in Latin America(all income levels) in 2000 to that in 2003?
Your response must be concise. 0.72. What is the ratio of the Aid flow (current US$) of Costa Rica in 2000 to that in 2003?
Give a very brief answer. 0.16. What is the ratio of the Aid flow (current US$) of Latin America(all income levels) in 2000 to that in 2004?
Offer a terse response. 0.52. What is the ratio of the Aid flow (current US$) in Costa Rica in 2000 to that in 2004?
Your answer should be compact. 0.16. What is the ratio of the Aid flow (current US$) of Latin America(all income levels) in 2003 to that in 2004?
Offer a terse response. 0.71. What is the ratio of the Aid flow (current US$) in Comoros in 2003 to that in 2004?
Your response must be concise. 2. What is the ratio of the Aid flow (current US$) in Costa Rica in 2003 to that in 2004?
Provide a short and direct response. 0.97. What is the difference between the highest and the second highest Aid flow (current US$) of Latin America(all income levels)?
Make the answer very short. 1.95e+08. What is the difference between the highest and the second highest Aid flow (current US$) of North America?
Your answer should be very brief. 10000. What is the difference between the highest and the lowest Aid flow (current US$) in Latin America(all income levels)?
Give a very brief answer. 5.15e+08. What is the difference between the highest and the lowest Aid flow (current US$) in North America?
Keep it short and to the point. 3.00e+04. What is the difference between the highest and the lowest Aid flow (current US$) of Comoros?
Your answer should be compact. 9.30e+05. What is the difference between the highest and the lowest Aid flow (current US$) of Costa Rica?
Ensure brevity in your answer.  8.91e+06. 